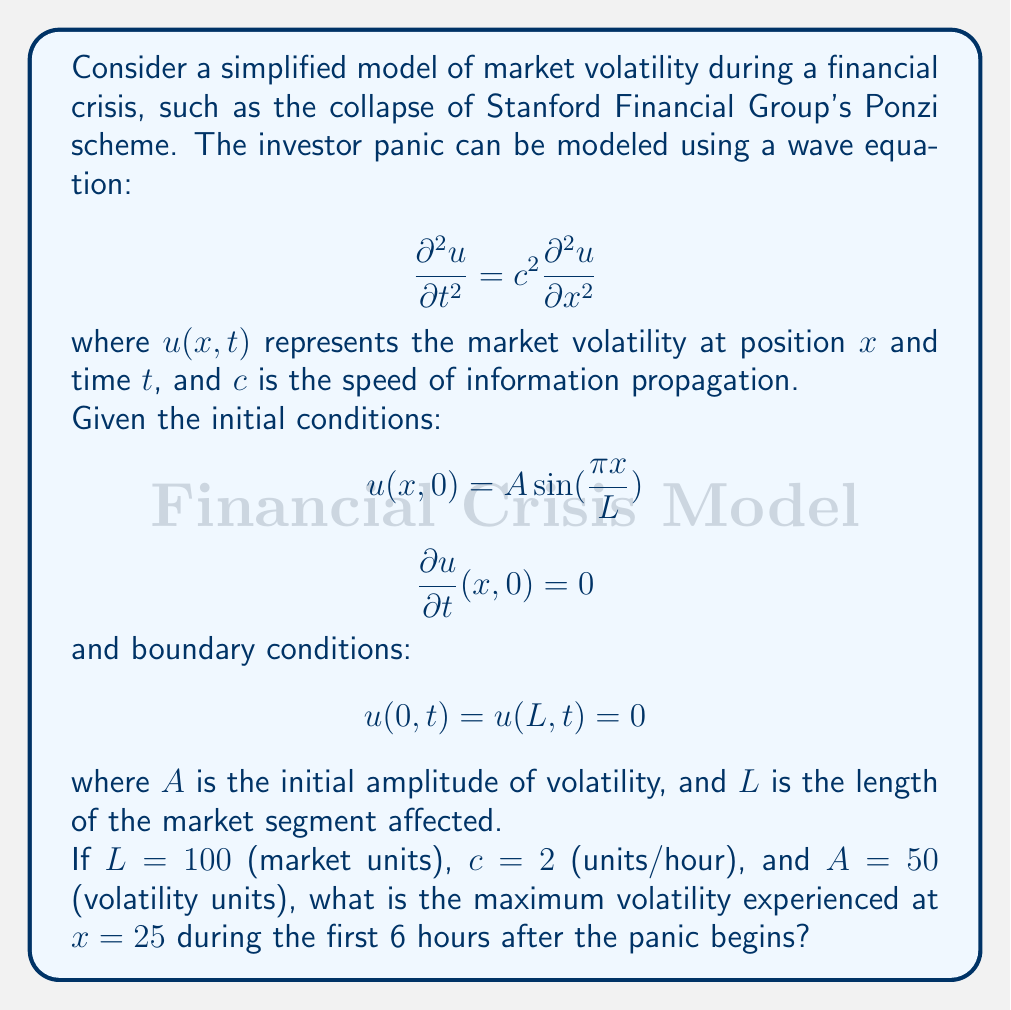Teach me how to tackle this problem. To solve this problem, we need to use the general solution of the wave equation with the given initial and boundary conditions. The solution takes the form:

$$u(x,t) = \sum_{n=1}^{\infty} \left(A_n \cos(\omega_n t) + B_n \sin(\omega_n t)\right) \sin(\frac{n\pi x}{L})$$

where $\omega_n = \frac{n\pi c}{L}$.

Given the initial conditions:

1. $u(x,0) = A\sin(\frac{\pi x}{L})$ implies that only the first term ($n=1$) in the series is non-zero, and $A_1 = A = 50$.
2. $\frac{\partial u}{\partial t}(x,0) = 0$ implies that $B_n = 0$ for all $n$.

Therefore, our solution simplifies to:

$$u(x,t) = 50 \cos(\frac{\pi c t}{L}) \sin(\frac{\pi x}{L})$$

Now, let's calculate the maximum volatility at $x = 25$ during the first 6 hours:

1. Substitute $x = 25$:
   $$u(25,t) = 50 \cos(\frac{\pi c t}{L}) \sin(\frac{25\pi}{100})$$

2. Simplify:
   $$u(25,t) = 50 \cos(\frac{\pi \cdot 2t}{100}) \sin(\frac{\pi}{4}) = 35.36 \cos(0.0628t)$$

3. The maximum value of cosine is 1, which occurs when its argument is a multiple of $2\pi$. However, we need to check if this maximum is reached within the first 6 hours.

4. The period of the cosine function is:
   $$T = \frac{2\pi}{0.0628} \approx 100 \text{ hours}$$

5. Since 6 hours is less than half the period, the maximum value will occur at $t = 0$.

Therefore, the maximum volatility at $x = 25$ during the first 6 hours is 35.36 volatility units.
Answer: 35.36 volatility units 